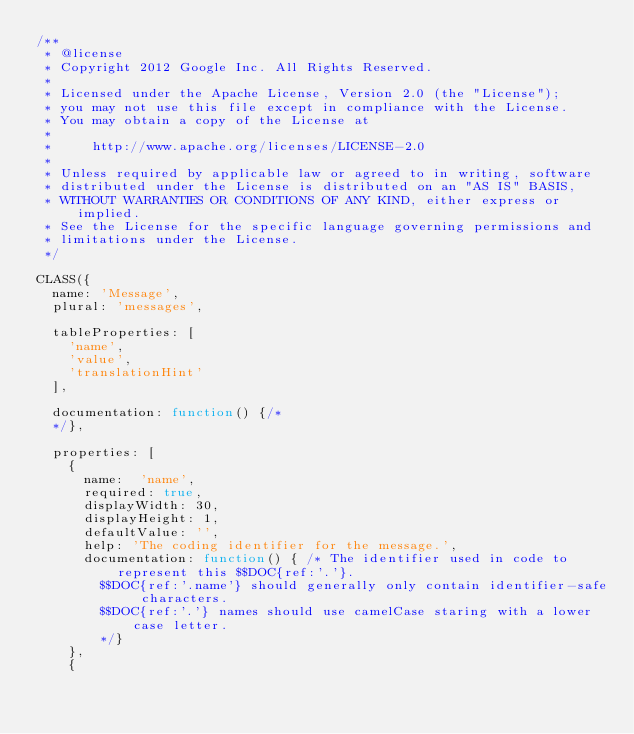Convert code to text. <code><loc_0><loc_0><loc_500><loc_500><_JavaScript_>/**
 * @license
 * Copyright 2012 Google Inc. All Rights Reserved.
 *
 * Licensed under the Apache License, Version 2.0 (the "License");
 * you may not use this file except in compliance with the License.
 * You may obtain a copy of the License at
 *
 *     http://www.apache.org/licenses/LICENSE-2.0
 *
 * Unless required by applicable law or agreed to in writing, software
 * distributed under the License is distributed on an "AS IS" BASIS,
 * WITHOUT WARRANTIES OR CONDITIONS OF ANY KIND, either express or implied.
 * See the License for the specific language governing permissions and
 * limitations under the License.
 */

CLASS({
  name: 'Message',
  plural: 'messages',

  tableProperties: [
    'name',
    'value',
    'translationHint'
  ],

  documentation: function() {/*
  */},

  properties: [
    {
      name:  'name',
      required: true,
      displayWidth: 30,
      displayHeight: 1,
      defaultValue: '',
      help: 'The coding identifier for the message.',
      documentation: function() { /* The identifier used in code to represent this $$DOC{ref:'.'}.
        $$DOC{ref:'.name'} should generally only contain identifier-safe characters.
        $$DOC{ref:'.'} names should use camelCase staring with a lower case letter.
        */}
    },
    {</code> 